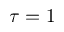Convert formula to latex. <formula><loc_0><loc_0><loc_500><loc_500>\tau = 1</formula> 